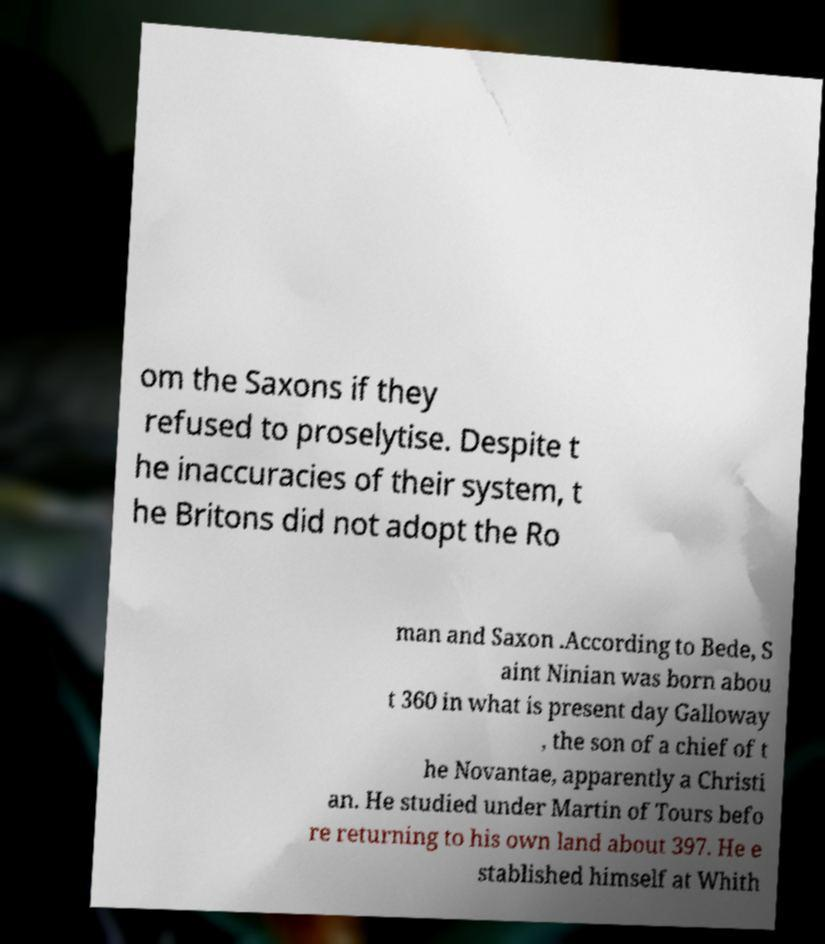Could you extract and type out the text from this image? om the Saxons if they refused to proselytise. Despite t he inaccuracies of their system, t he Britons did not adopt the Ro man and Saxon .According to Bede, S aint Ninian was born abou t 360 in what is present day Galloway , the son of a chief of t he Novantae, apparently a Christi an. He studied under Martin of Tours befo re returning to his own land about 397. He e stablished himself at Whith 